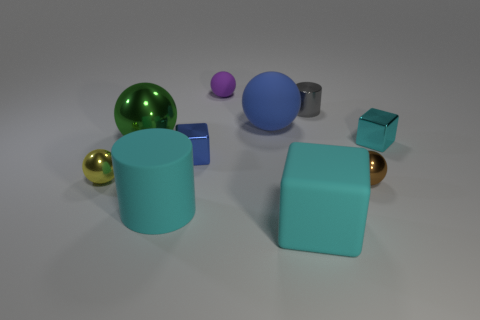Is the color of the metal cube right of the big cyan matte cube the same as the cylinder in front of the tiny cyan metal object?
Provide a short and direct response. Yes. Are there any cyan matte cylinders of the same size as the blue rubber sphere?
Your answer should be very brief. Yes. What is the material of the small object that is both on the left side of the metallic cylinder and behind the large green shiny ball?
Keep it short and to the point. Rubber. How many shiny things are either tiny blue cubes or blue things?
Make the answer very short. 1. The blue object that is made of the same material as the small yellow object is what shape?
Ensure brevity in your answer.  Cube. How many tiny shiny things are both behind the small yellow metallic sphere and on the right side of the small gray shiny object?
Make the answer very short. 1. There is a cylinder that is behind the green metal sphere; how big is it?
Your answer should be compact. Small. How many other things are there of the same color as the large matte ball?
Your answer should be very brief. 1. There is a cube that is in front of the big cyan matte object on the left side of the purple matte object; what is it made of?
Your answer should be compact. Rubber. There is a tiny metal ball to the right of the yellow metal sphere; is its color the same as the rubber cylinder?
Offer a very short reply. No. 